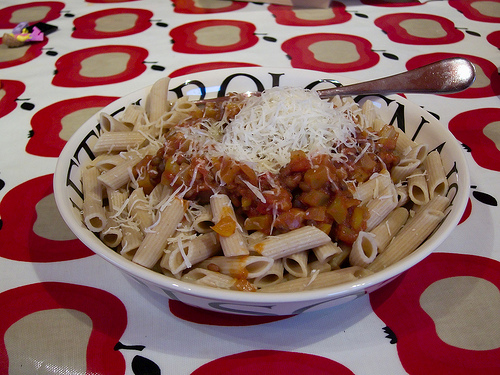<image>
Is there a food on the bowl? Yes. Looking at the image, I can see the food is positioned on top of the bowl, with the bowl providing support. Where is the pasta in relation to the table? Is it on the table? No. The pasta is not positioned on the table. They may be near each other, but the pasta is not supported by or resting on top of the table. Is there a noodle in front of the bowl? No. The noodle is not in front of the bowl. The spatial positioning shows a different relationship between these objects. 